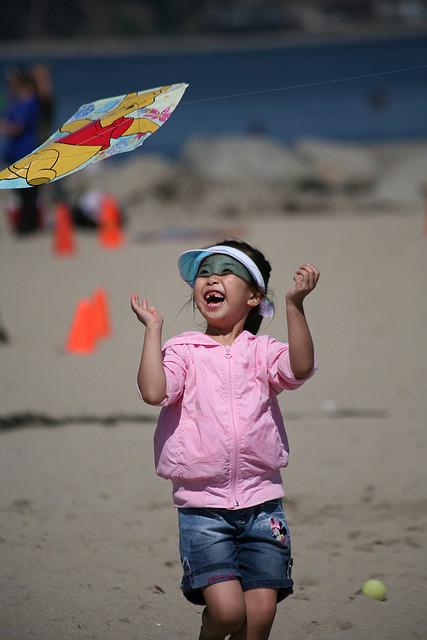Where is the yellow ball?
Concise answer only. In sand. How many balls in picture?
Quick response, please. 1. What is on her head?
Write a very short answer. Visor. 